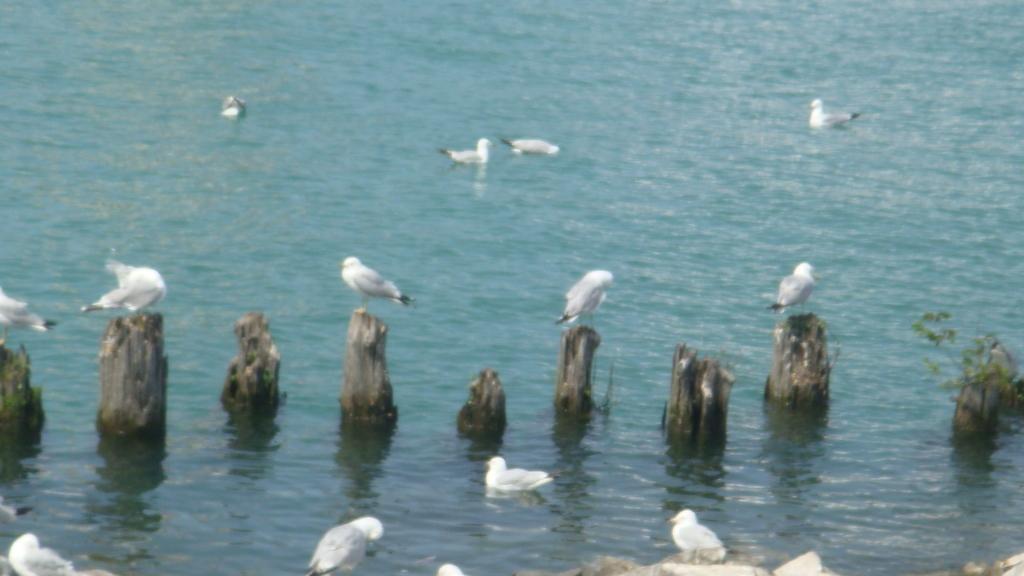Can you describe this image briefly? This image consists of water. There are so many cranes and ducks in the middle. They are in white color. 